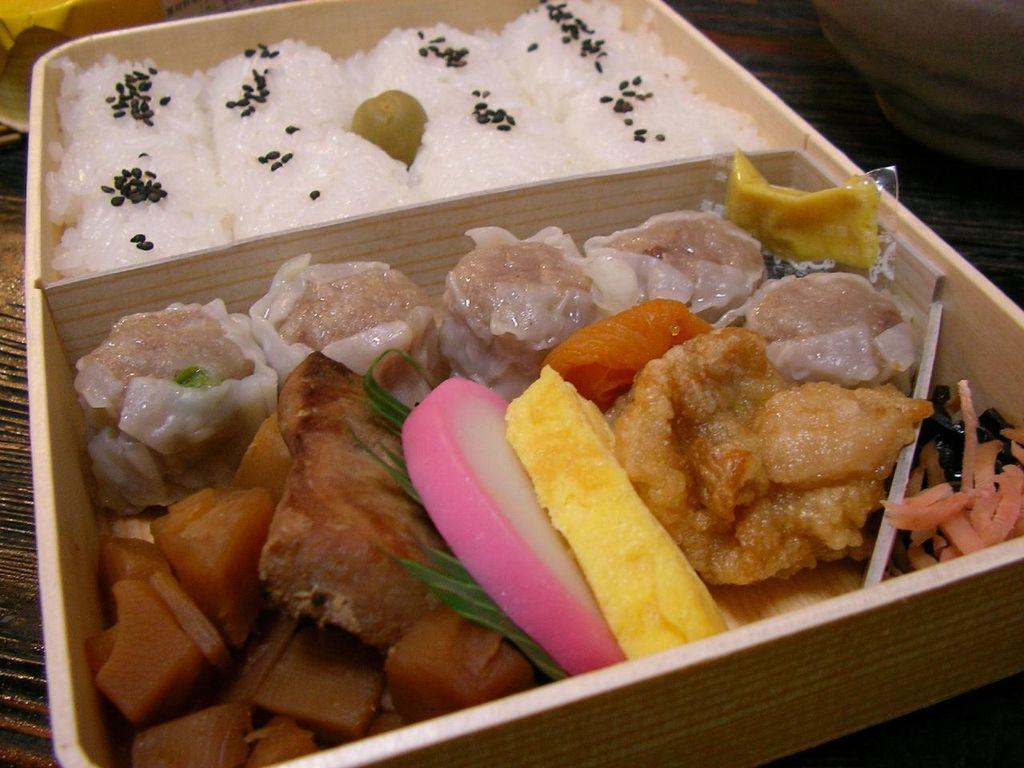What is the main object in the image? There is a box in the image. Where is the box located? The box is on a surface. What is inside the box? There is rice with sesame seeds and another unspecified item in the box. Are there any other food items visible in the image? Yes, there are other food items in the image. What type of quilt is covering the rice in the box? There is no quilt present in the image; it is a box containing rice with sesame seeds and another unspecified item. How does the heart shape appear in the image? There is no heart shape present in the image. 